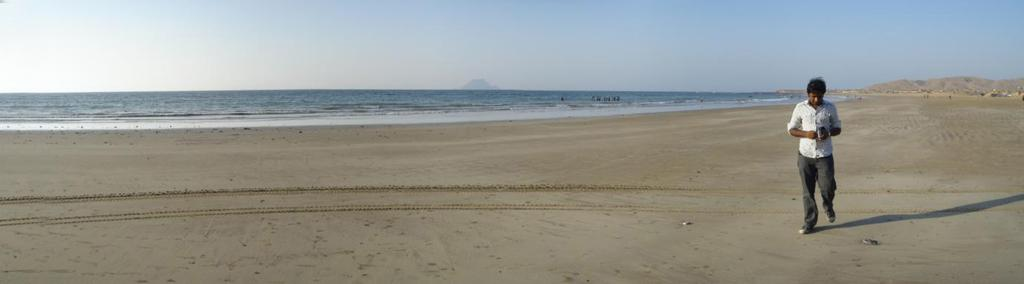Who is present in the image? There is a man in the image. What is the man doing in the image? The man is walking on the seashore. What can be seen in the background of the image? There is sea visible in the background of the image, as well as hills. What is visible at the top of the image? The sky is visible at the top of the image. What type of competition is the man participating in on the seashore? There is no indication of a competition in the image; the man is simply walking on the seashore. Can you recite the verse that the man is saying while walking on the seashore? There is no verse being recited in the image; the man is not speaking or singing. 